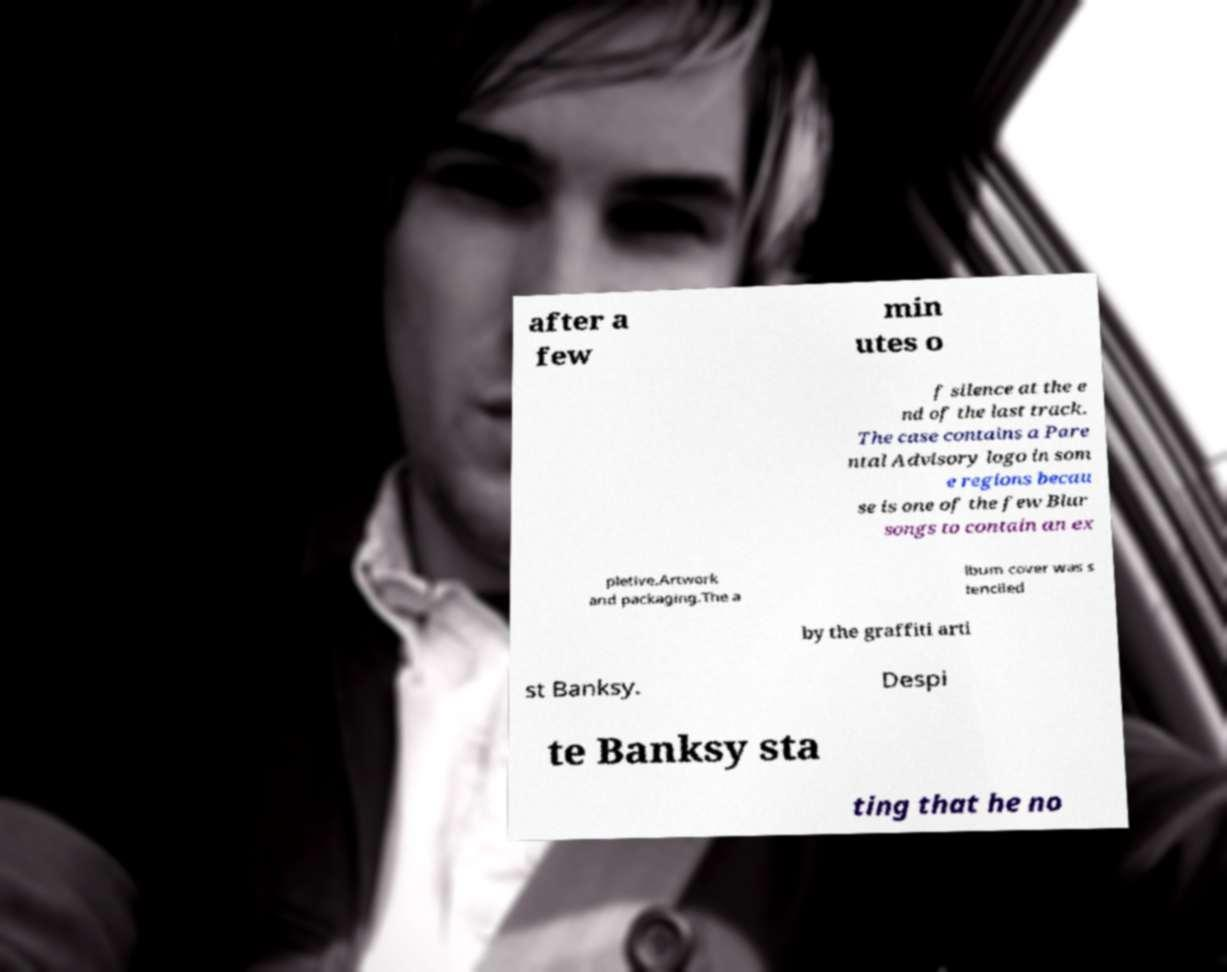For documentation purposes, I need the text within this image transcribed. Could you provide that? after a few min utes o f silence at the e nd of the last track. The case contains a Pare ntal Advisory logo in som e regions becau se is one of the few Blur songs to contain an ex pletive.Artwork and packaging.The a lbum cover was s tenciled by the graffiti arti st Banksy. Despi te Banksy sta ting that he no 